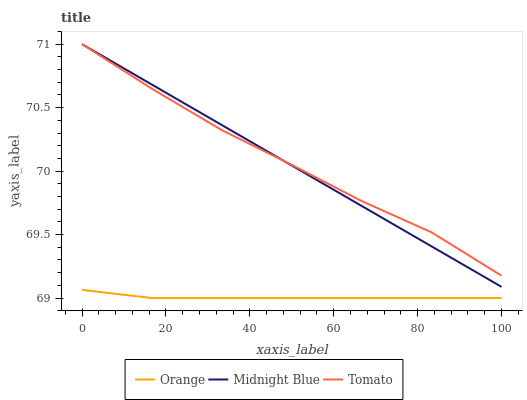Does Orange have the minimum area under the curve?
Answer yes or no. Yes. Does Tomato have the maximum area under the curve?
Answer yes or no. Yes. Does Midnight Blue have the minimum area under the curve?
Answer yes or no. No. Does Midnight Blue have the maximum area under the curve?
Answer yes or no. No. Is Midnight Blue the smoothest?
Answer yes or no. Yes. Is Tomato the roughest?
Answer yes or no. Yes. Is Tomato the smoothest?
Answer yes or no. No. Is Midnight Blue the roughest?
Answer yes or no. No. Does Midnight Blue have the lowest value?
Answer yes or no. No. Is Orange less than Midnight Blue?
Answer yes or no. Yes. Is Tomato greater than Orange?
Answer yes or no. Yes. Does Orange intersect Midnight Blue?
Answer yes or no. No. 